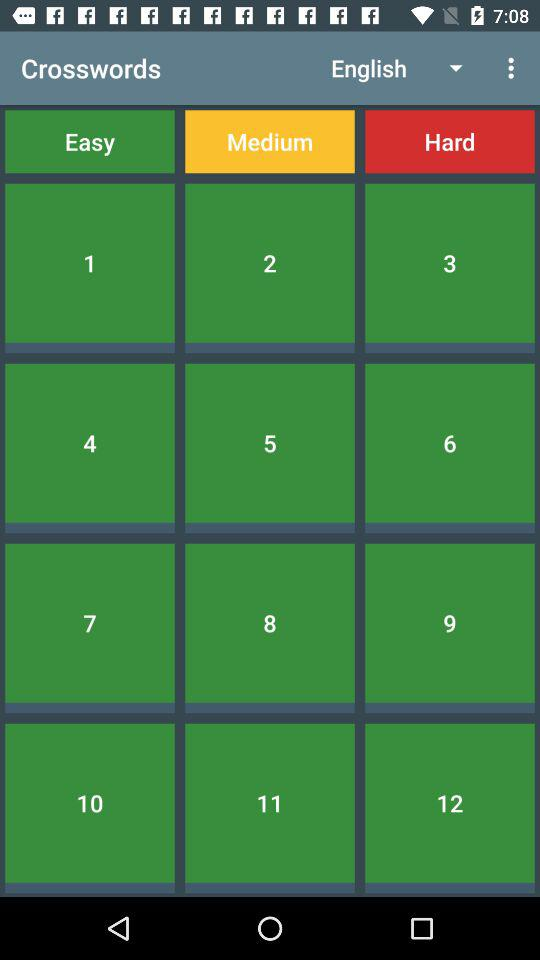Which language is selected? The selected language is English. 